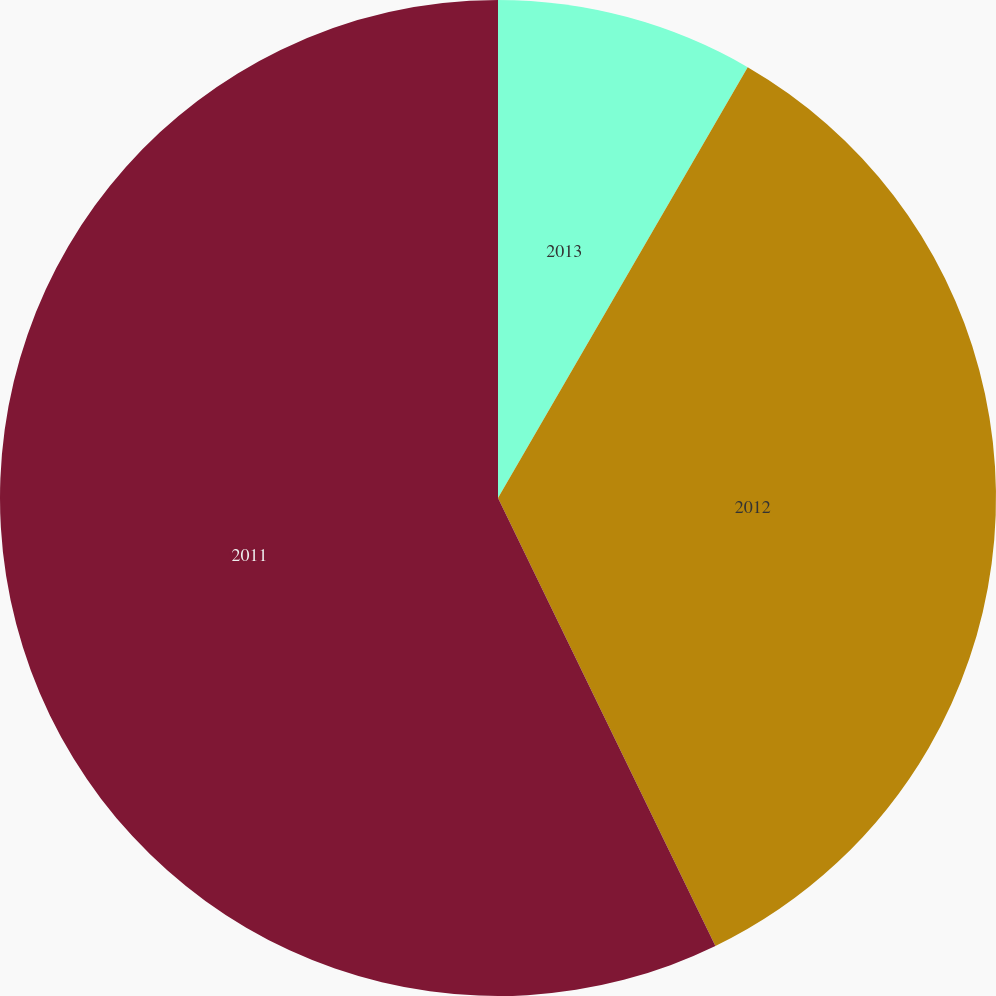Convert chart. <chart><loc_0><loc_0><loc_500><loc_500><pie_chart><fcel>2013<fcel>2012<fcel>2011<nl><fcel>8.36%<fcel>34.45%<fcel>57.19%<nl></chart> 